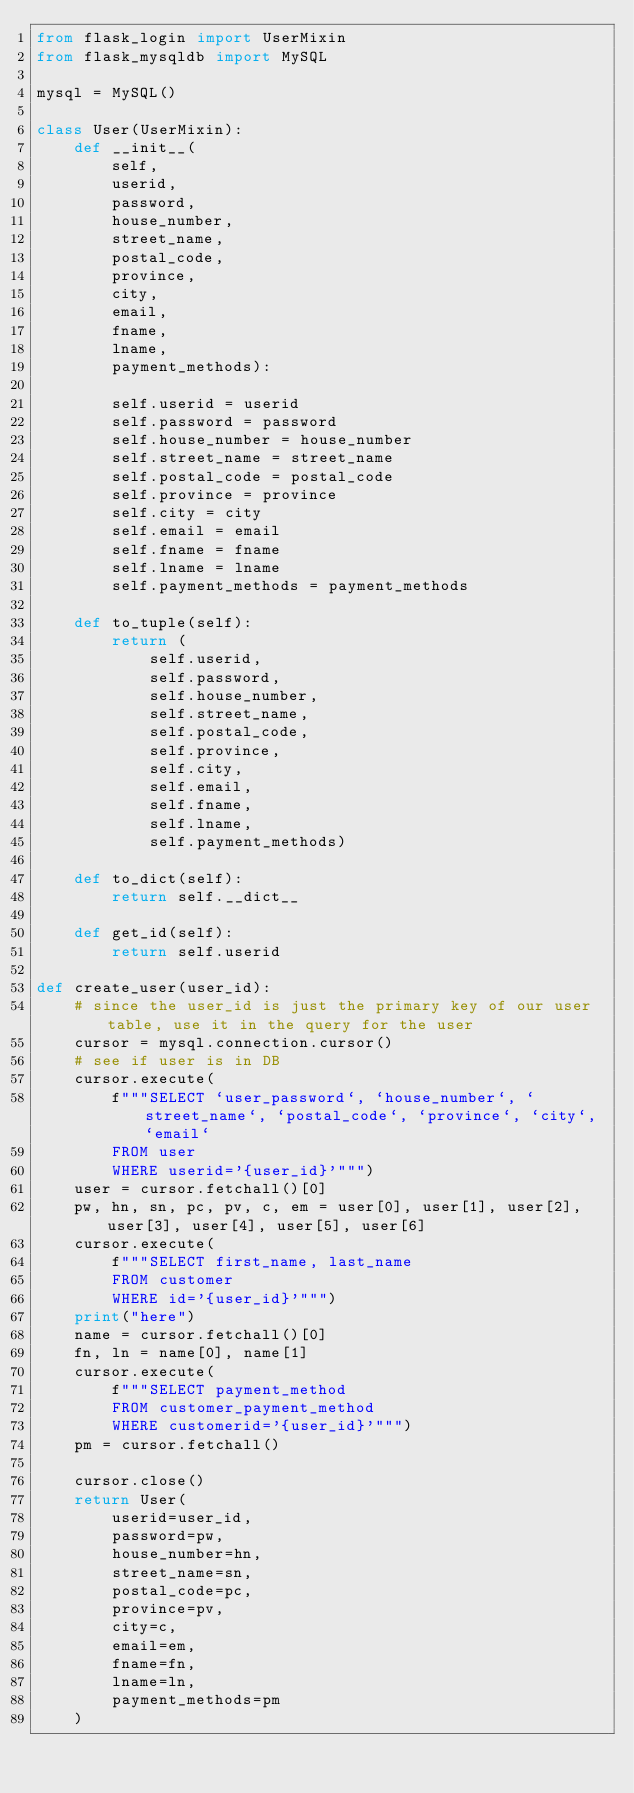<code> <loc_0><loc_0><loc_500><loc_500><_Python_>from flask_login import UserMixin
from flask_mysqldb import MySQL

mysql = MySQL()

class User(UserMixin):
    def __init__(
        self,
        userid,
        password,
        house_number,
        street_name,
        postal_code,
        province,
        city,
        email,
        fname,
        lname,
        payment_methods):

        self.userid = userid
        self.password = password
        self.house_number = house_number
        self.street_name = street_name
        self.postal_code = postal_code
        self.province = province
        self.city = city
        self.email = email
        self.fname = fname
        self.lname = lname
        self.payment_methods = payment_methods

    def to_tuple(self):
        return (
            self.userid, 
            self.password, 
            self.house_number,
            self.street_name,
            self.postal_code,
            self.province,
            self.city,
            self.email,
            self.fname,
            self.lname,
            self.payment_methods)

    def to_dict(self):
        return self.__dict__

    def get_id(self):
        return self.userid

def create_user(user_id):
    # since the user_id is just the primary key of our user table, use it in the query for the user
    cursor = mysql.connection.cursor()
    # see if user is in DB
    cursor.execute(
        f"""SELECT `user_password`, `house_number`, `street_name`, `postal_code`, `province`, `city`, `email` 
        FROM user 
        WHERE userid='{user_id}'""")
    user = cursor.fetchall()[0]
    pw, hn, sn, pc, pv, c, em = user[0], user[1], user[2], user[3], user[4], user[5], user[6]
    cursor.execute(
        f"""SELECT first_name, last_name 
        FROM customer
        WHERE id='{user_id}'""")
    print("here")
    name = cursor.fetchall()[0]
    fn, ln = name[0], name[1]
    cursor.execute(
        f"""SELECT payment_method
        FROM customer_payment_method
        WHERE customerid='{user_id}'""")
    pm = cursor.fetchall()

    cursor.close()
    return User(
        userid=user_id,
        password=pw,
        house_number=hn,
        street_name=sn,
        postal_code=pc,
        province=pv,
        city=c,
        email=em,
        fname=fn,
        lname=ln,
        payment_methods=pm
    )</code> 